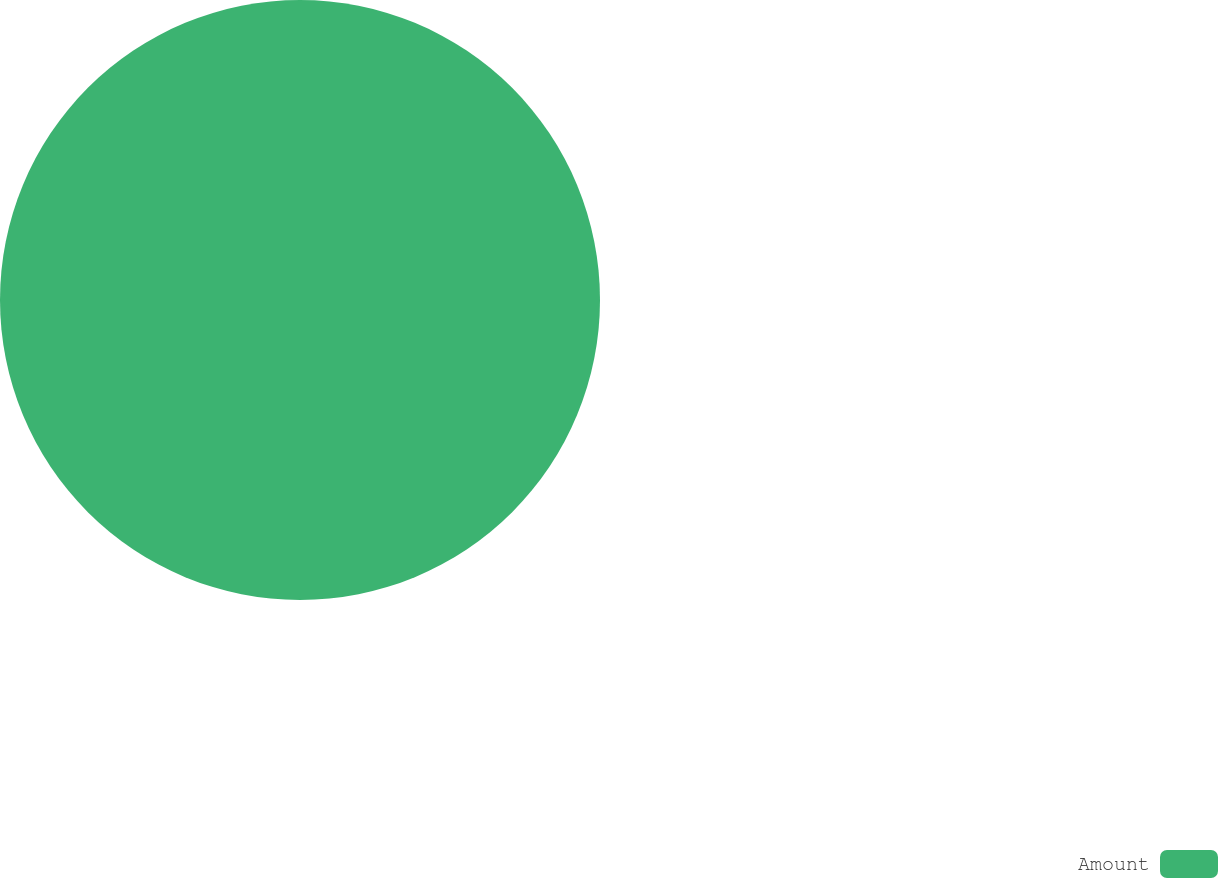Convert chart. <chart><loc_0><loc_0><loc_500><loc_500><pie_chart><fcel>Amount<nl><fcel>100.0%<nl></chart> 